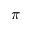<formula> <loc_0><loc_0><loc_500><loc_500>\pi</formula> 